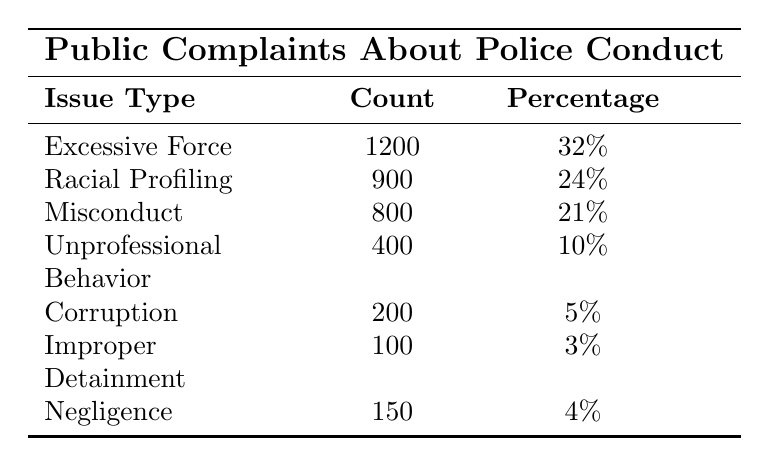What is the total number of public complaints about police conduct? To find the total number of public complaints, we add the counts of all issue types together: 1200 + 900 + 800 + 400 + 200 + 100 + 150 = 2850.
Answer: 2850 Which issue type has the highest number of complaints? The issue type with the highest count of complaints is "Excessive Force," with a count of 1200.
Answer: Excessive Force What percentage of complaints are related to "Corruption"? According to the table, "Corruption" has a percentage of 5%, which is directly stated in the data.
Answer: 5% If we combine "Improper Detainment" and "Negligence," what percentage do they represent of total complaints? The count of "Improper Detainment" is 100 and "Negligence" is 150. Their combined count is 100 + 150 = 250. This constitutes 250 out of 2850 total complaints. To find the percentage: (250 / 2850) * 100 ≈ 8.77%.
Answer: Approximately 8.77% Are there more complaints about "Racial Profiling" or "Misconduct"? "Racial Profiling" has 900 complaints while "Misconduct" has 800 complaints. Since 900 is greater than 800, there are more complaints about "Racial Profiling."
Answer: More complaints about Racial Profiling What is the difference in the number of complaints between "Excessive Force" and "Unprofessional Behavior"? The count for "Excessive Force" is 1200 and for "Unprofessional Behavior" is 400. To find the difference, we subtract: 1200 - 400 = 800.
Answer: 800 If we categorize all complaints into two groups: complaints that involve force and those that do not, how many complaints are in each group? "Excessive Force" would be in the first group with 1200 complaints. The other complaints (Racial Profiling, Misconduct, Unprofessional Behavior, Corruption, Improper Detainment, Negligence) total: 900 + 800 + 400 + 200 + 100 + 150 = 2550. Therefore, Group 1: 1200 and Group 2: 2550.
Answer: Group 1: 1200, Group 2: 2550 What is the percentage of complaints that fall under "Misconduct" compared to the overall complaints? The percentage of "Misconduct" is directly given as 21%. To confirm, we divide its count by the total number: (800/2850) * 100 ≈ 28.07%, which differs from the stated percentage. Thus, the table states 21% for "Misconduct."
Answer: 21% Which two issue types together make up the least percentage of total complaints? "Improper Detainment" (3%) and "Corruption" (5%) together make: 3% + 5% = 8%. This is less than any other pairing of issue types.
Answer: 8% In terms of raw complaint counts, how significant is the "Negligence" when compared to the other categories? "Negligence" has a count of 150, which can be compared to the total complaints (2850). It represents: (150 / 2850) * 100 ≈ 5.26%. Other categories like "Excessive Force" and "Racial Profiling" have counts significantly larger than this.
Answer: Negligible (5.26%) 